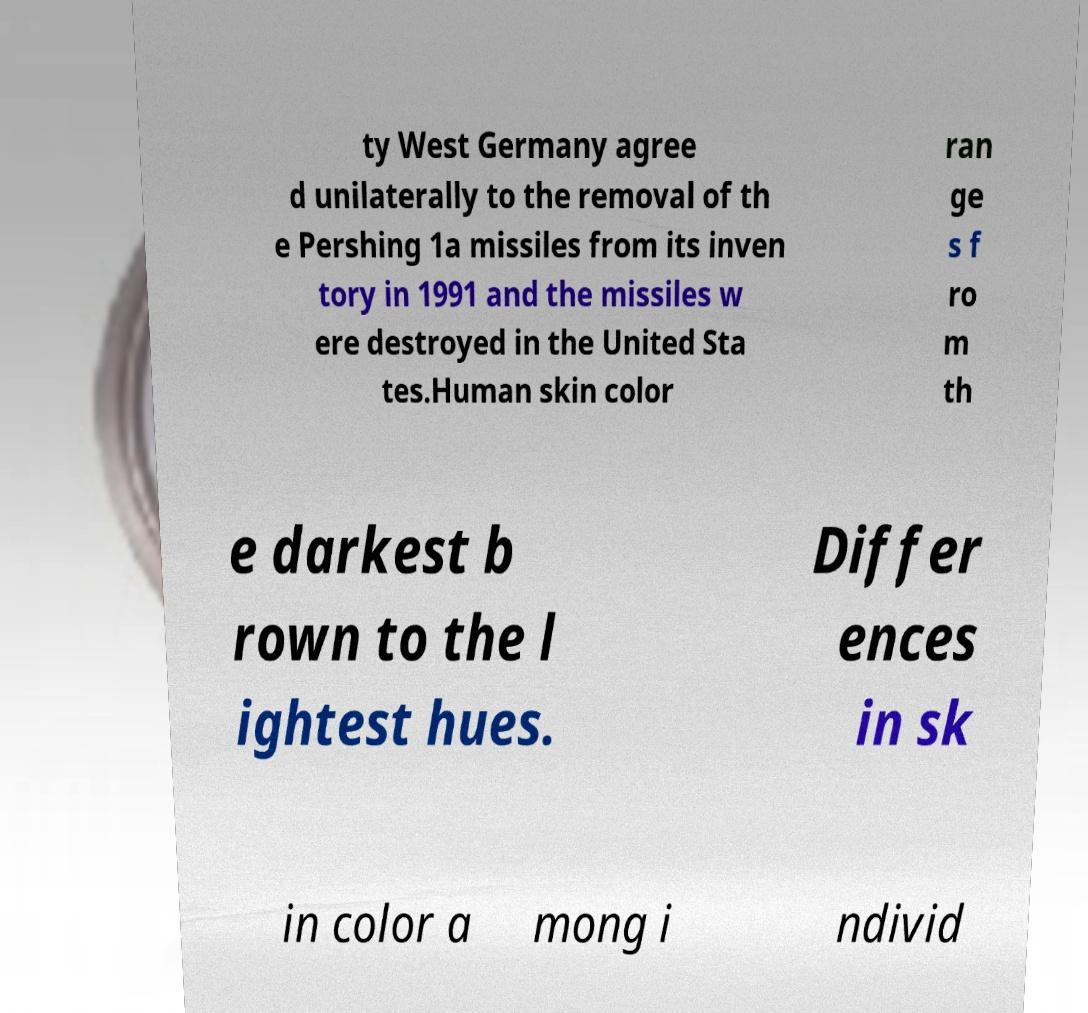Can you read and provide the text displayed in the image?This photo seems to have some interesting text. Can you extract and type it out for me? ty West Germany agree d unilaterally to the removal of th e Pershing 1a missiles from its inven tory in 1991 and the missiles w ere destroyed in the United Sta tes.Human skin color ran ge s f ro m th e darkest b rown to the l ightest hues. Differ ences in sk in color a mong i ndivid 